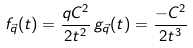<formula> <loc_0><loc_0><loc_500><loc_500>f _ { \vec { q } } ( t ) = \frac { q C ^ { 2 } } { 2 t ^ { 2 } } \, g _ { \vec { q } } ( t ) = \frac { - C ^ { 2 } } { 2 t ^ { 3 } }</formula> 